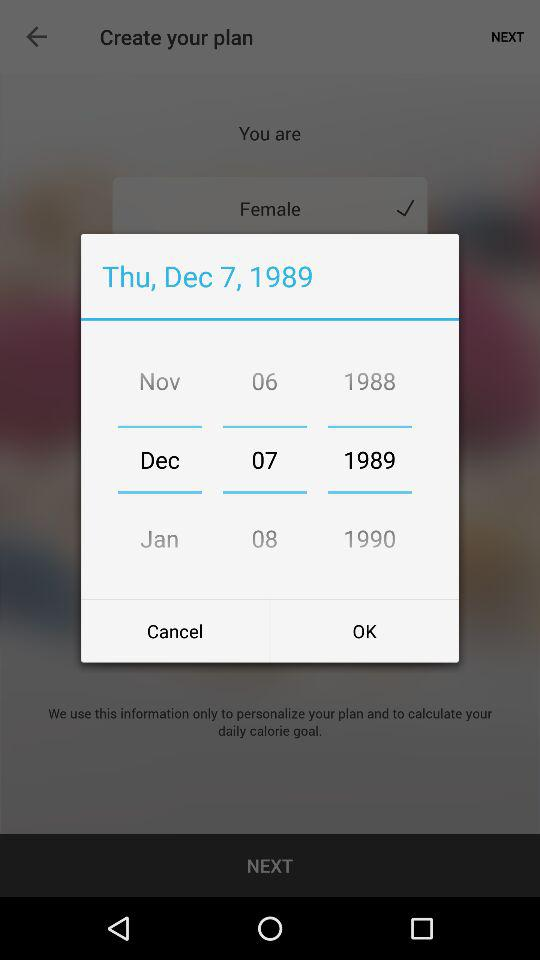What is the day? The day is Thursday. 